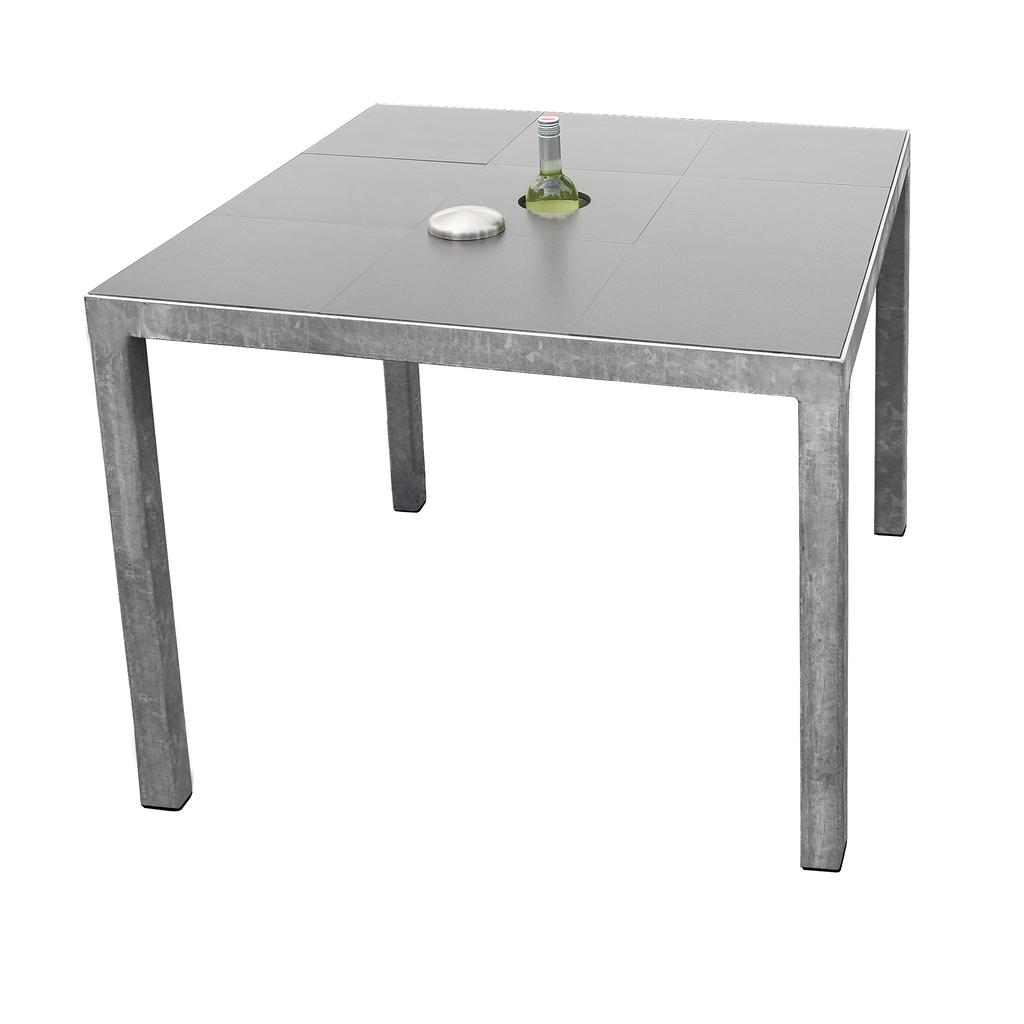What object is present in the image that can hold liquid? There is a bottle in the image that can hold liquid. What is the small, round object in the image? There is a cap in the image. Where are the bottle and cap located in the image? The bottle and cap are on a table. How many legs can be seen on the locket in the image? There is no locket present in the image, and therefore no legs can be seen on it. 